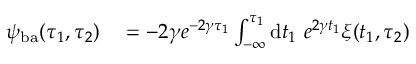Convert formula to latex. <formula><loc_0><loc_0><loc_500><loc_500>\begin{array} { r l } { \psi _ { b a } ( \tau _ { 1 } , \tau _ { 2 } ) } & = - 2 \gamma e ^ { - 2 \gamma \tau _ { 1 } } \int _ { - \infty } ^ { \tau _ { 1 } } d t _ { 1 } e ^ { 2 \gamma t _ { 1 } } \xi ( t _ { 1 } , \tau _ { 2 } ) } \end{array}</formula> 